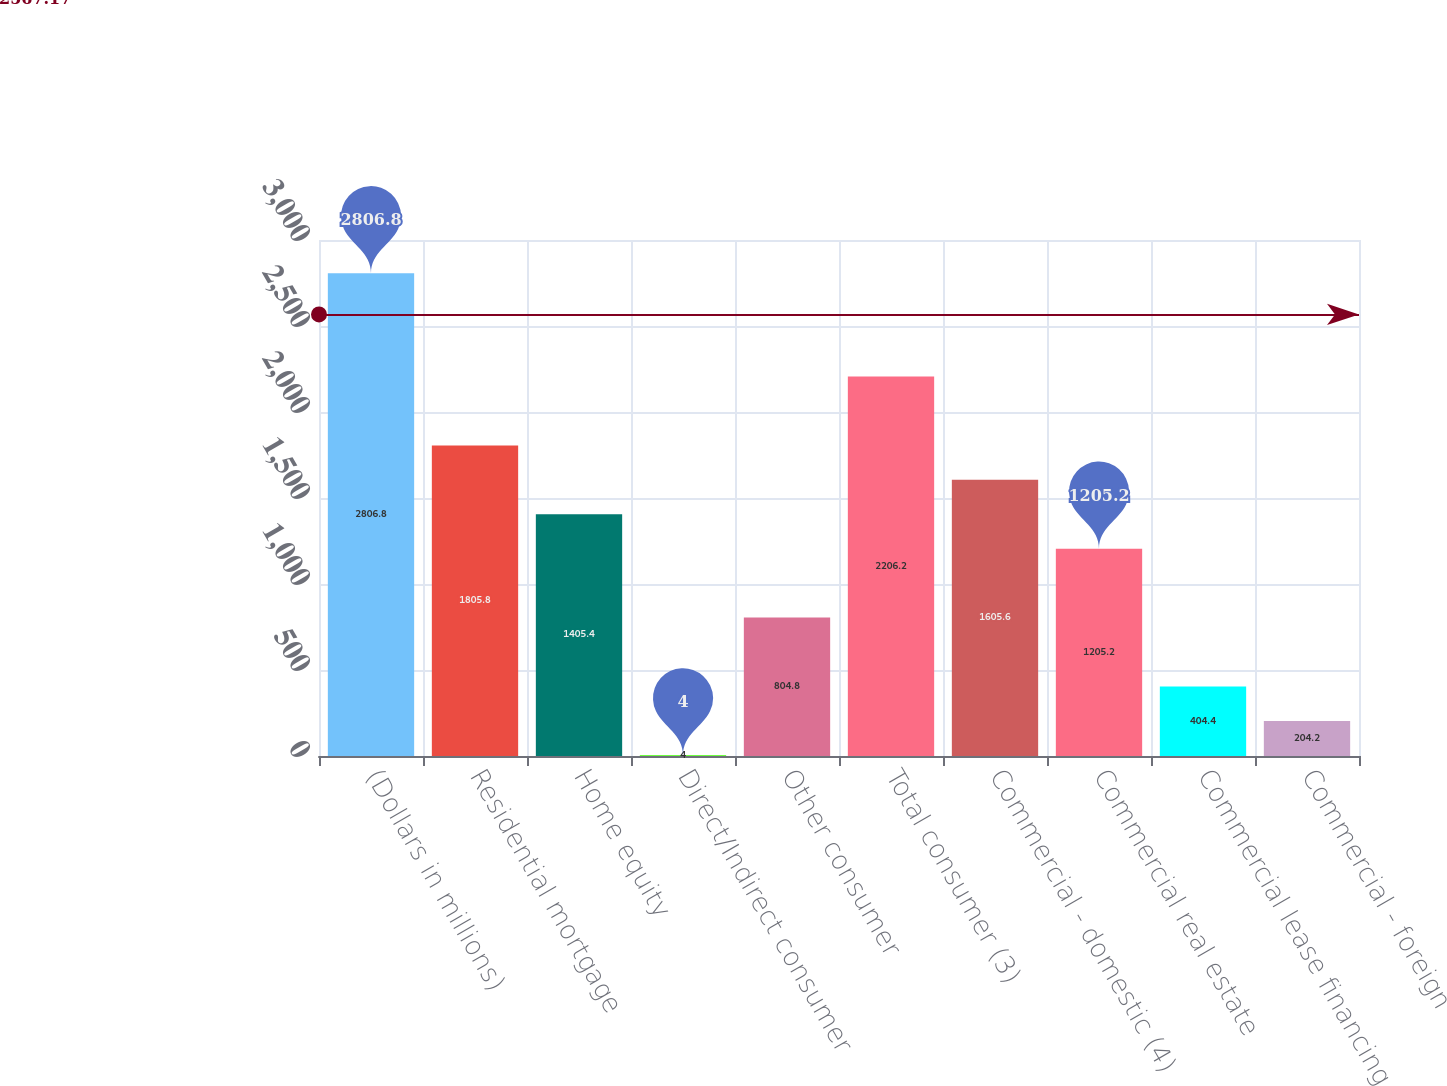Convert chart to OTSL. <chart><loc_0><loc_0><loc_500><loc_500><bar_chart><fcel>(Dollars in millions)<fcel>Residential mortgage<fcel>Home equity<fcel>Direct/Indirect consumer<fcel>Other consumer<fcel>Total consumer (3)<fcel>Commercial - domestic (4)<fcel>Commercial real estate<fcel>Commercial lease financing<fcel>Commercial - foreign<nl><fcel>2806.8<fcel>1805.8<fcel>1405.4<fcel>4<fcel>804.8<fcel>2206.2<fcel>1605.6<fcel>1205.2<fcel>404.4<fcel>204.2<nl></chart> 